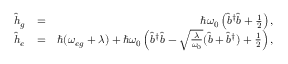Convert formula to latex. <formula><loc_0><loc_0><loc_500><loc_500>\begin{array} { r l r } { \hat { h } _ { g } } & { = } & { \hbar { \omega } _ { 0 } \left ( \hat { b } ^ { \dagger } \hat { b } + \frac { 1 } { 2 } \right ) , } \\ { \hat { h } _ { e } } & { = } & { \hbar { ( } \omega _ { e g } + \lambda ) + \hbar { \omega } _ { 0 } \left ( \hat { b } ^ { \dagger } \hat { b } - \sqrt { \frac { \lambda } { \omega _ { 0 } } } ( \hat { b } + \hat { b } ^ { \dagger } ) + \frac { 1 } { 2 } \right ) , } \end{array}</formula> 